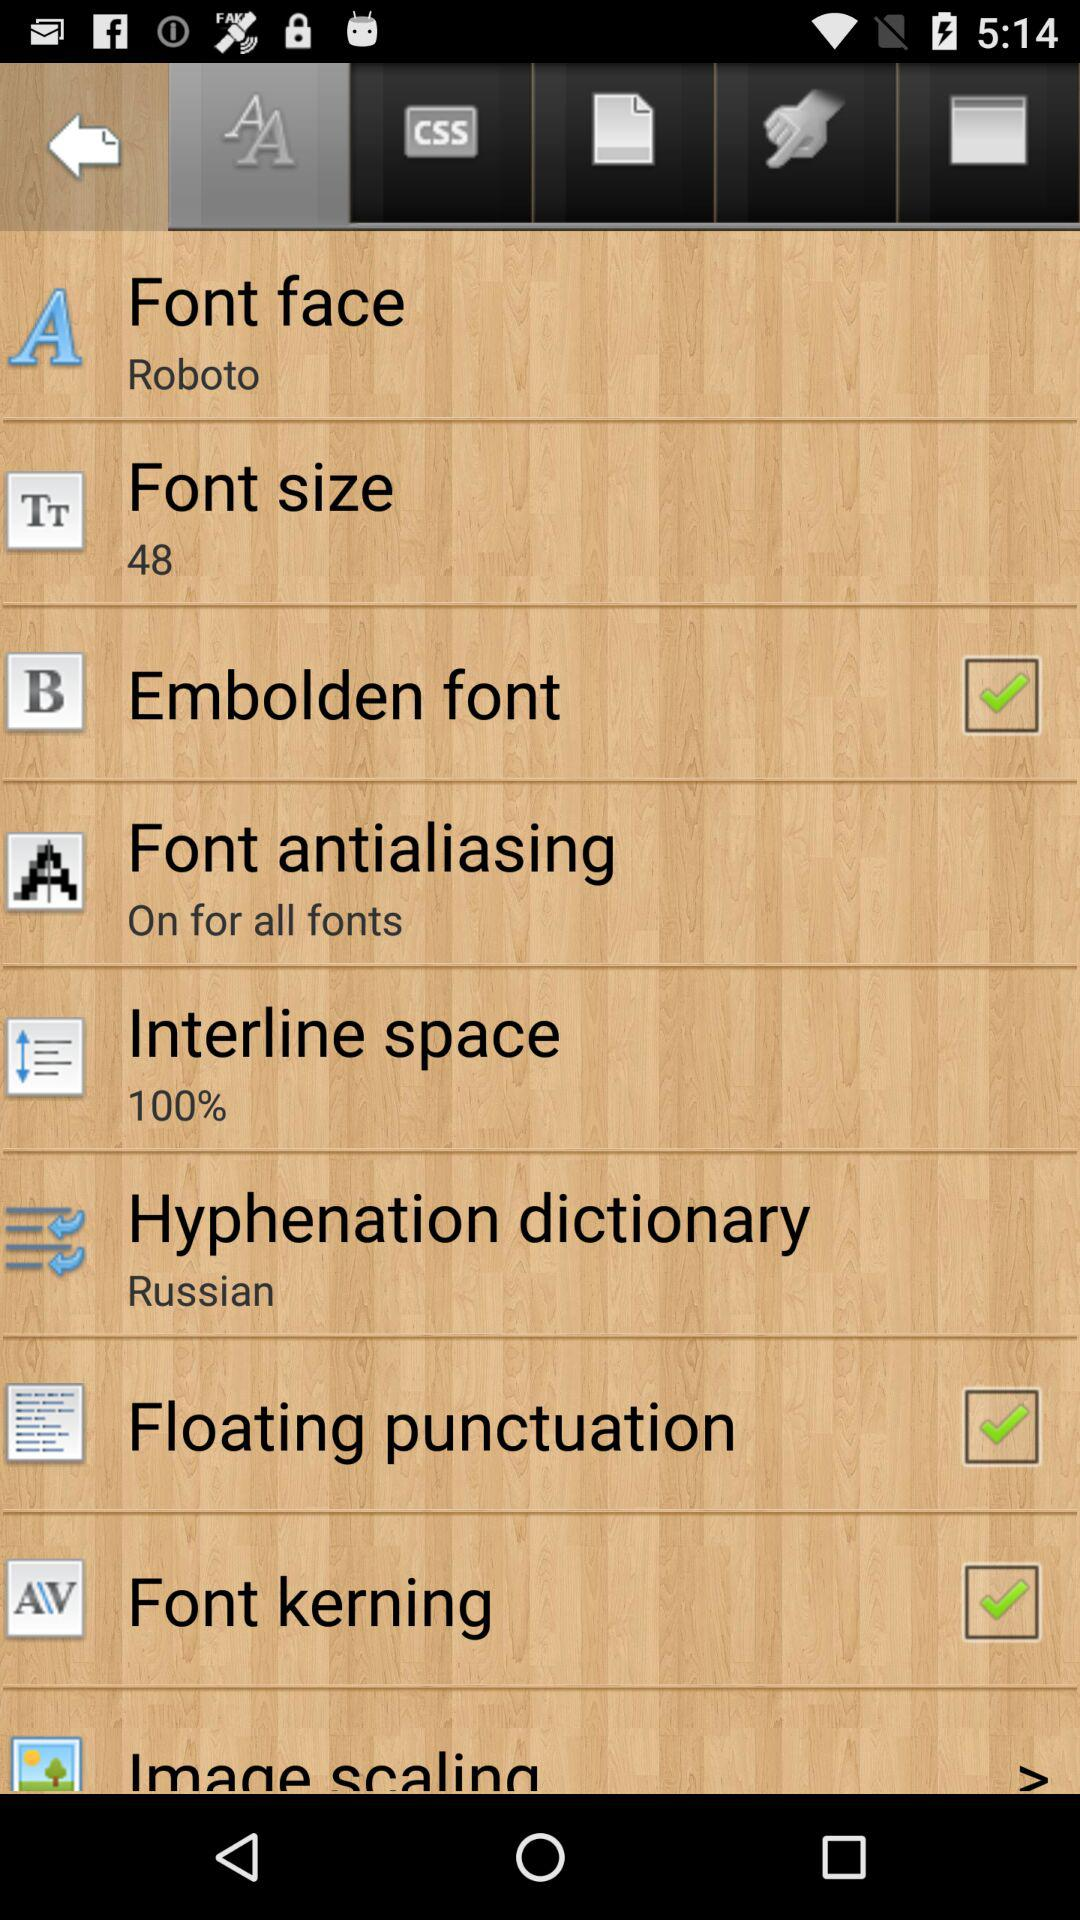What font face is selected? The selected font face is "Roboto". 